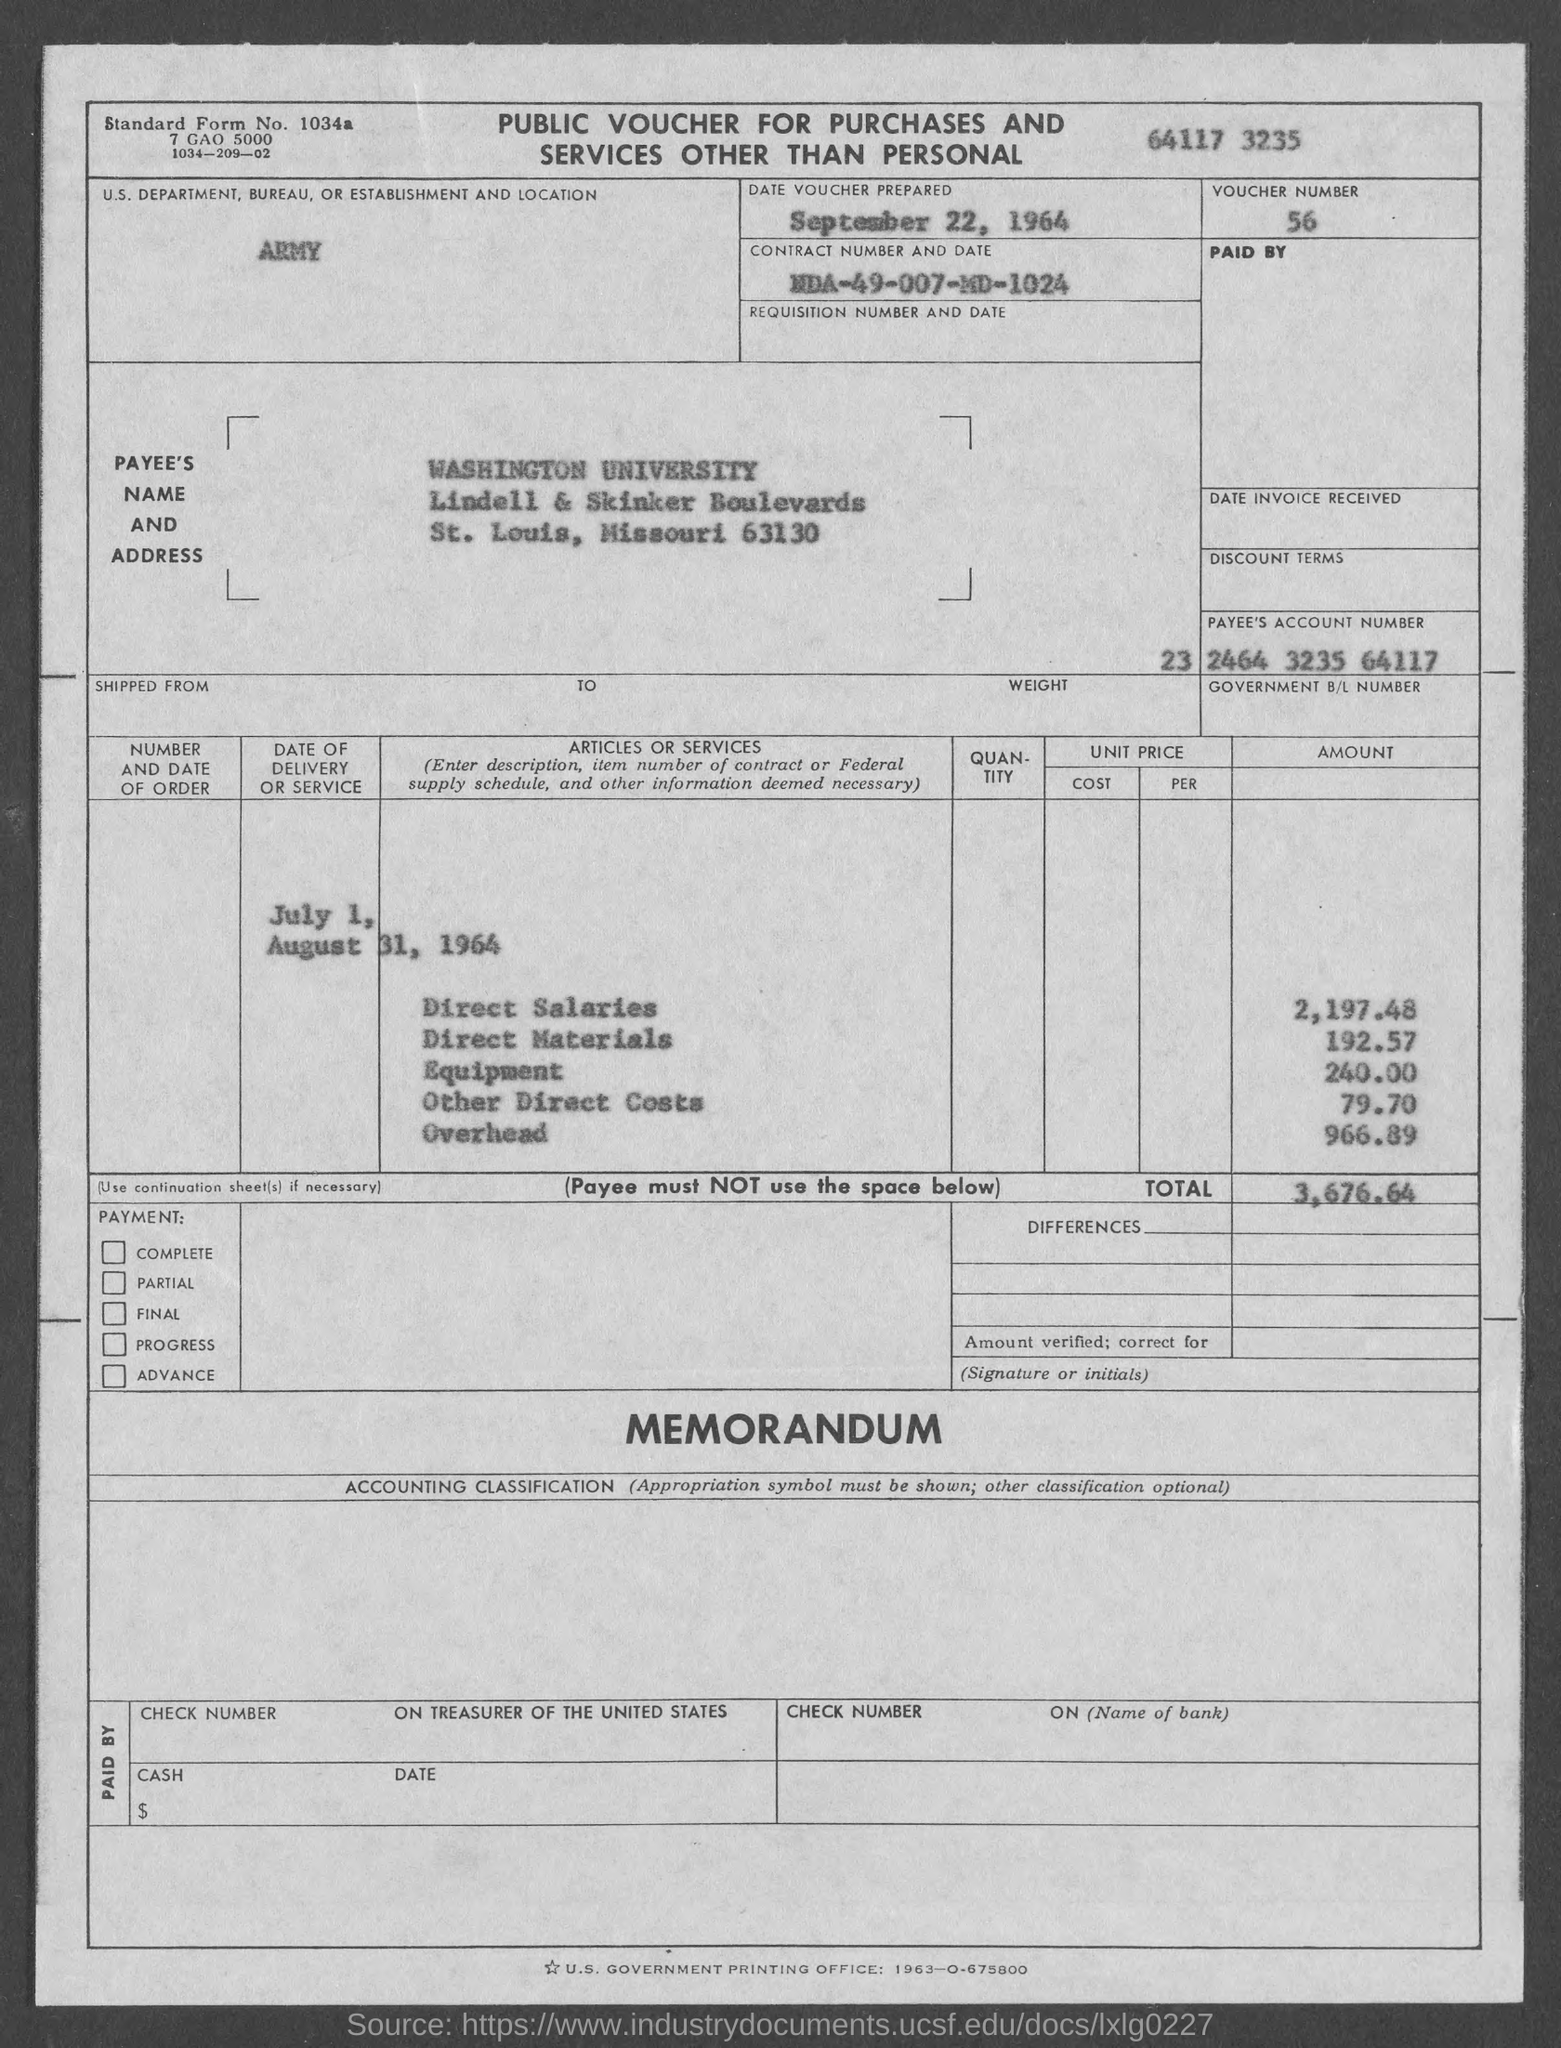What is the Voucher Number?
Offer a very short reply. 56. What is the Date voucher prepared?
Ensure brevity in your answer.  September 22, 1964. What is the Contract Number and Date?
Make the answer very short. NDA-49-007-MD-1024. What is the Payee's Name?
Make the answer very short. Washington University. What is the Payee's Account Number?
Your answer should be compact. 23 2464 3235 64117. What is the Direct salaries amount?
Your answer should be very brief. 2,197.48. What is the Direct materials amount?
Your response must be concise. 192.57. What is the Equipment amount?
Your answer should be compact. 240.00. What is the Overhead Amount?
Keep it short and to the point. 966.89. What is the Total amount?
Provide a short and direct response. 3,676.64. 